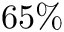<formula> <loc_0><loc_0><loc_500><loc_500>6 5 \%</formula> 